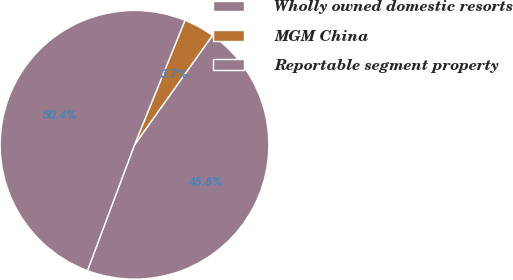Convert chart. <chart><loc_0><loc_0><loc_500><loc_500><pie_chart><fcel>Wholly owned domestic resorts<fcel>MGM China<fcel>Reportable segment property<nl><fcel>45.85%<fcel>3.72%<fcel>50.43%<nl></chart> 